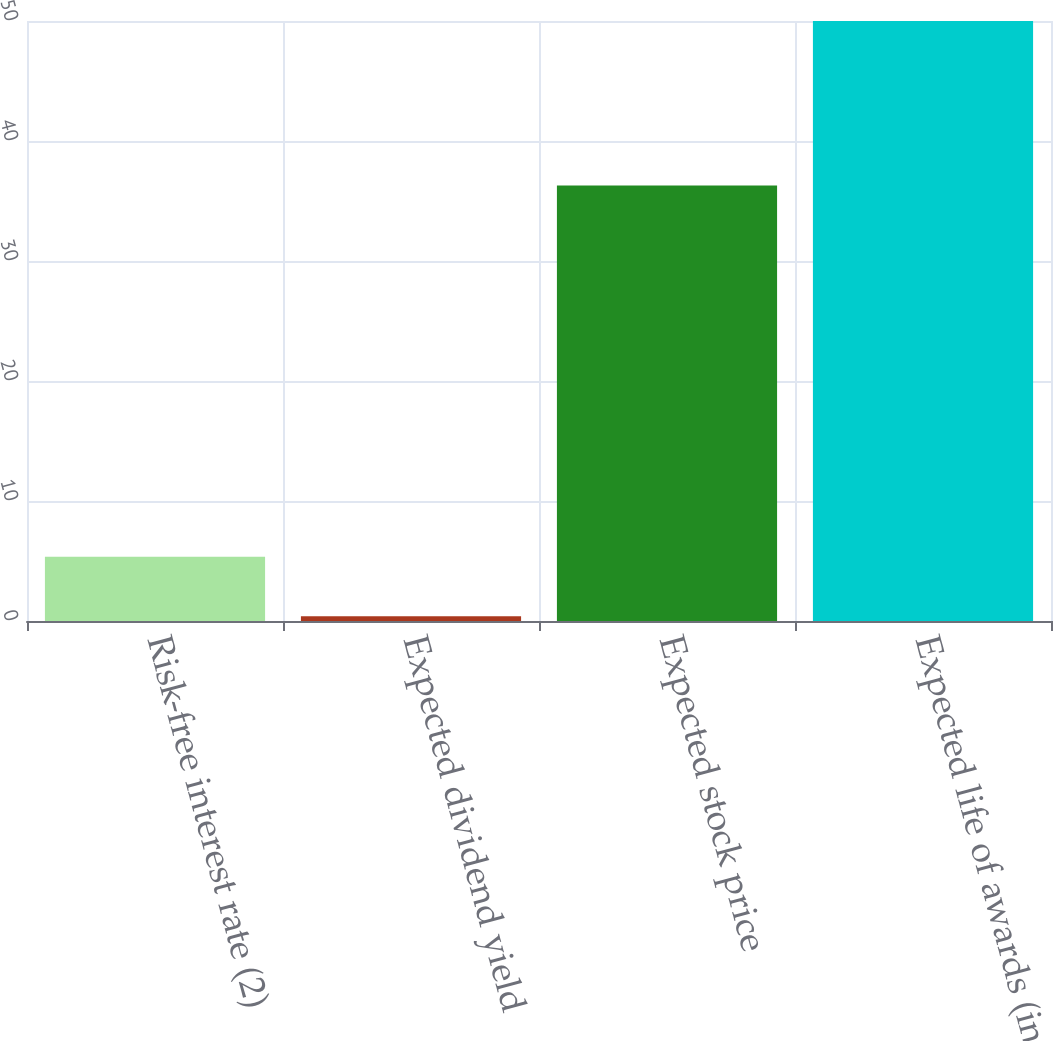<chart> <loc_0><loc_0><loc_500><loc_500><bar_chart><fcel>Risk-free interest rate (2)<fcel>Expected dividend yield<fcel>Expected stock price<fcel>Expected life of awards (in<nl><fcel>5.36<fcel>0.4<fcel>36.3<fcel>50<nl></chart> 